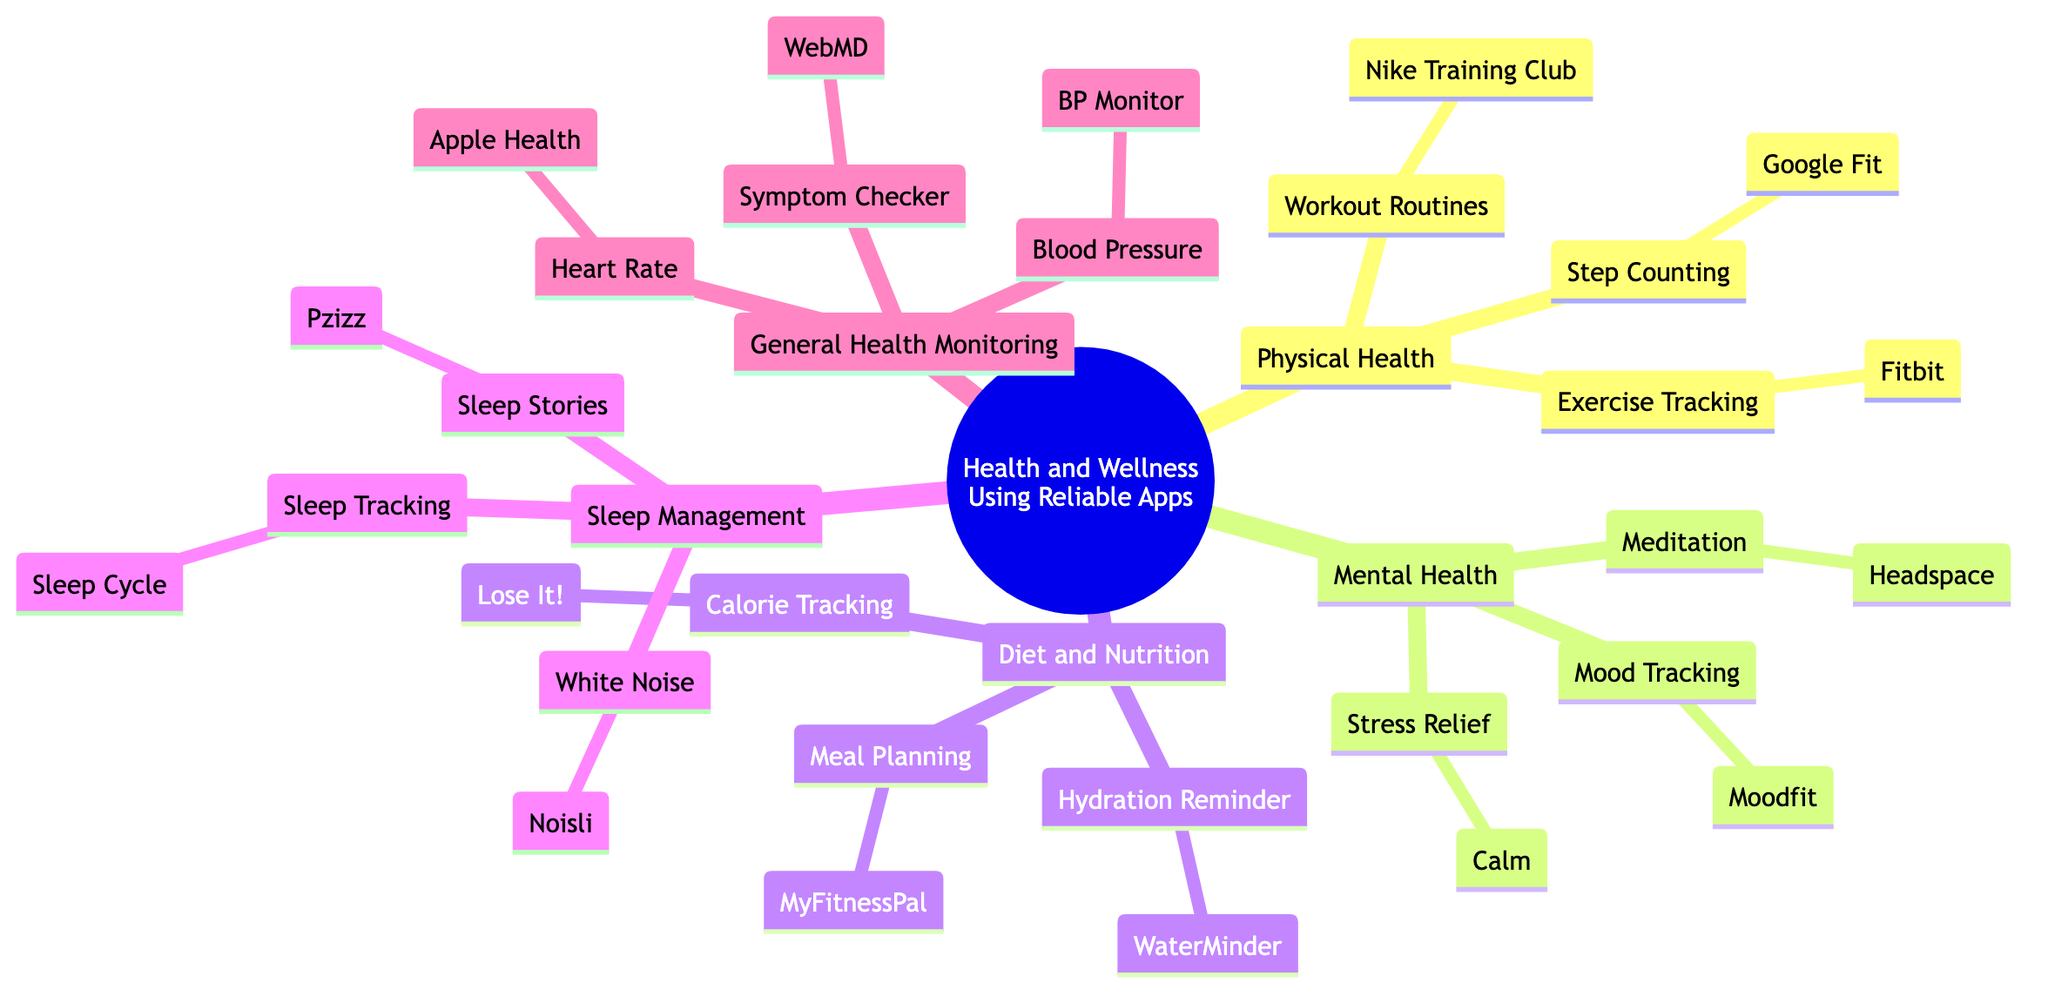What are the three categories under "Mental Health"? The diagram lists "Meditation," "Stress Relief," and "Mood Tracking" as the three categories under "Mental Health." These are found directly as sub-nodes connected to "Mental Health."
Answer: Meditation, Stress Relief, Mood Tracking How many apps are listed under "Diet and Nutrition"? In the diagram, there are three apps detailed under "Diet and Nutrition": "MyFitnessPal," "Lose It!" and "WaterMinder." Hence, counting these gives a total of three apps.
Answer: 3 Which app is used for calorie tracking? The app for "Calorie Tracking," as identified in the diagram under "Diet and Nutrition," is "Lose It!" This app is directly linked to the node "Calorie Tracking."
Answer: Lose It! What does "Sleep Cycle" do? The diagram indicates that "Sleep Cycle" is a category under "Sleep Management" specifically for "Sleep Tracking." Therefore, its function relates to tracking sleep patterns.
Answer: Sleep Tracking Which two apps are listed for "Sleep Management"? The diagram details three apps under the "Sleep Management" category: "Sleep Cycle," "Noisli," and "Pzizz." Hence, the two apps mentioned from this category can be any two taken from this list, but all three are included.
Answer: Sleep Cycle, Noisli What is the purpose of "Headspace"? According to the diagram, "Headspace" is associated with "Meditation" under the "Mental Health" category. This indicates that its purpose is to aid in meditation practices.
Answer: Meditation How many distinct categories are listed in the diagram? The diagram organizes content into five distinct categories: "Physical Health," "Mental Health," "Diet and Nutrition," "Sleep Management," and "General Health Monitoring." Counting these gives a total of five categories.
Answer: 5 Which app is linked to "Hydration Reminder"? The app connected to the "Hydration Reminder" node under the "Diet and Nutrition" category is "WaterMinder," as shown in the diagram.
Answer: WaterMinder What category does "Apple Health" fall under? The diagram categorizes "Apple Health" under "General Health Monitoring." It directly connects to that main category in the mind map.
Answer: General Health Monitoring 